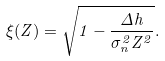Convert formula to latex. <formula><loc_0><loc_0><loc_500><loc_500>\xi ( Z ) = \sqrt { 1 - \frac { \Delta h } { \sigma _ { n } ^ { 2 } Z ^ { 2 } } } .</formula> 